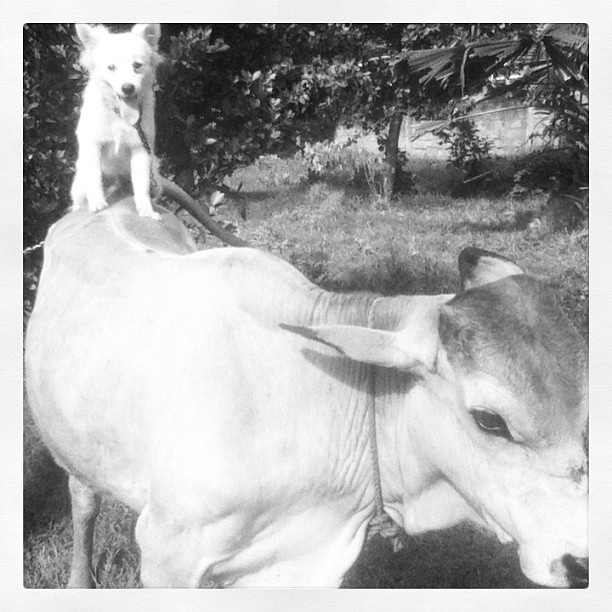Describe the objects in this image and their specific colors. I can see cow in whitesmoke, white, darkgray, gray, and black tones and dog in whitesmoke, white, darkgray, gray, and black tones in this image. 